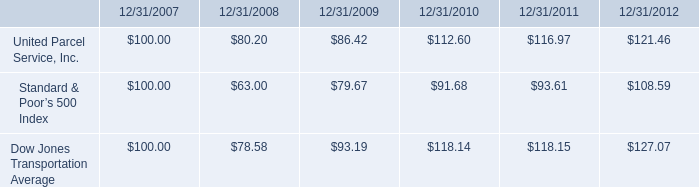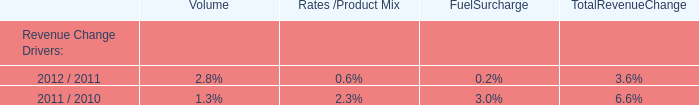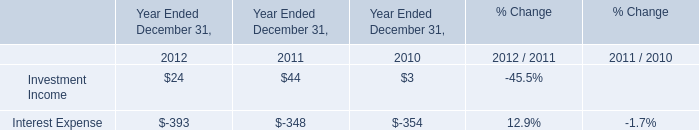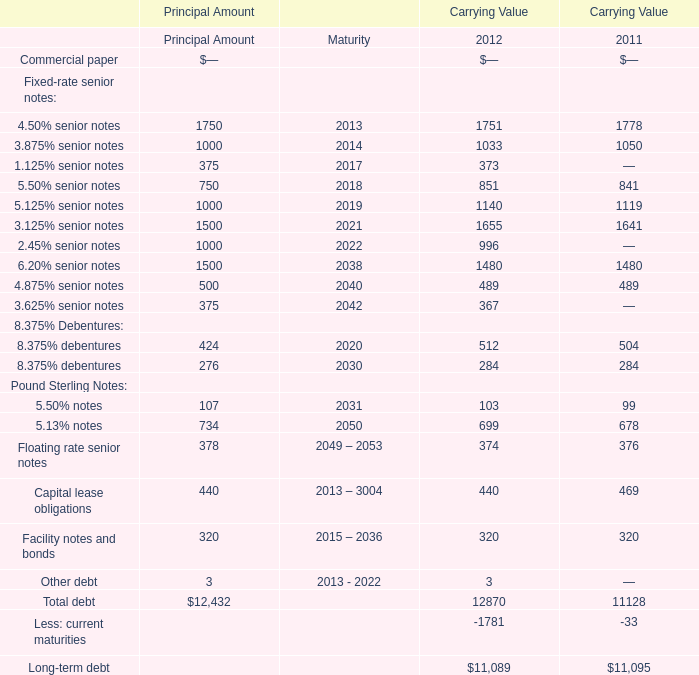What is the sum of 4.50% senior notes in 2012 and 2011 forCarrying Value 
Computations: (1751 + 1778)
Answer: 3529.0. 